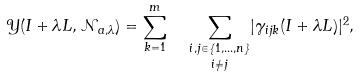Convert formula to latex. <formula><loc_0><loc_0><loc_500><loc_500>\mathcal { Y } ( I + \lambda L , \mathcal { N } _ { a , \lambda } ) = \sum ^ { m } _ { k = 1 } \ \ { \underset { i \not = j } { \underset { i , j \in \{ 1 , \dots , n \} } \sum } } | \gamma _ { i j k } ( I + \lambda L ) | ^ { 2 } ,</formula> 